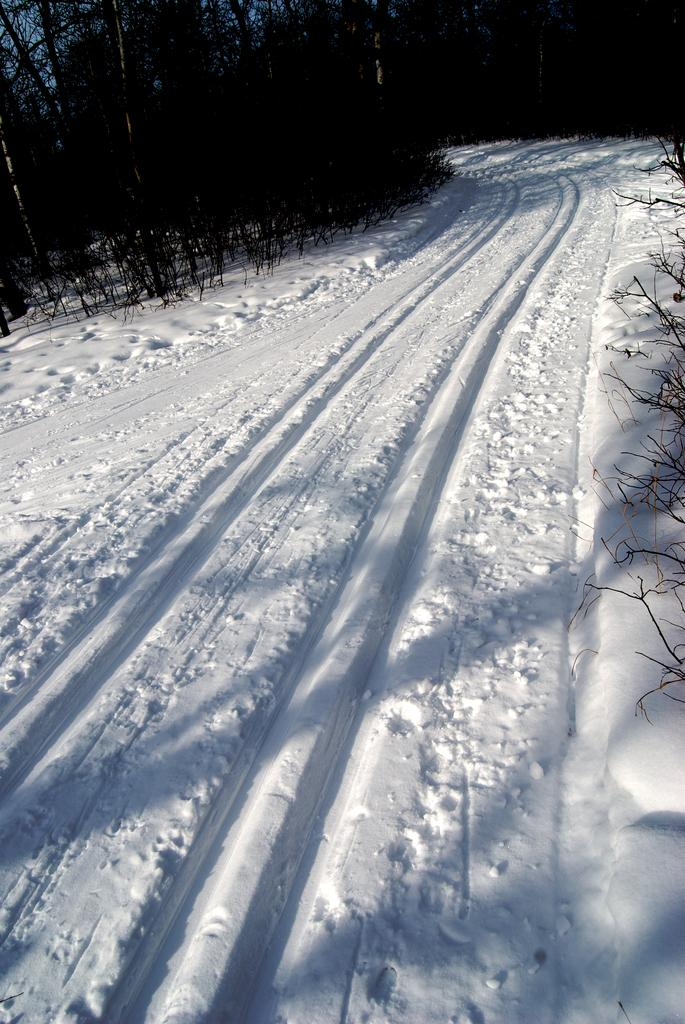What is the main feature in the foreground of the image? There is a snow path in the foreground of the image. What type of vegetation can be seen alongside the snow path? Trees are present on either side of the snow path. What type of hat is the snow wearing in the image? There is no snow wearing a hat in the image; it is a natural occurrence and not an anthropomorphic character. 